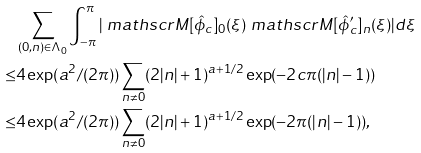Convert formula to latex. <formula><loc_0><loc_0><loc_500><loc_500>& \sum _ { ( 0 , n ) \in \Lambda _ { 0 } } \int _ { - \pi } ^ { \pi } | \ m a t h s c r { M } [ \hat { \phi } _ { c } ] _ { 0 } ( \xi ) \ m a t h s c r { M } [ \hat { \phi } ^ { \prime } _ { c } ] _ { n } ( \xi ) | d \xi \\ \leq & 4 \exp ( a ^ { 2 } / ( 2 \pi ) ) \sum _ { n \neq 0 } ( 2 | n | + 1 ) ^ { a + 1 / 2 } \exp ( - 2 c \pi ( | n | - 1 ) ) \\ \leq & 4 \exp ( a ^ { 2 } / ( 2 \pi ) ) \sum _ { n \neq 0 } ( 2 | n | + 1 ) ^ { a + 1 / 2 } \exp ( - 2 \pi ( | n | - 1 ) ) ,</formula> 